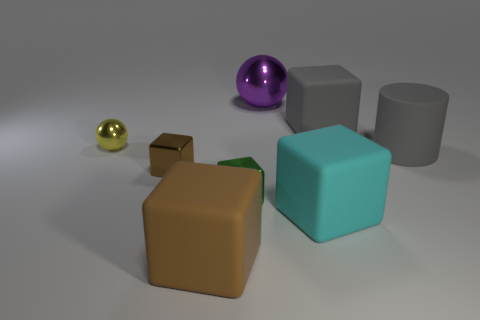There is a rubber cube on the left side of the purple metallic ball; is it the same size as the sphere to the right of the large brown rubber thing?
Offer a very short reply. Yes. There is a brown object in front of the brown metal block; how big is it?
Give a very brief answer. Large. Are there any big shiny things of the same color as the large cylinder?
Your answer should be compact. No. Are there any large gray matte cubes on the left side of the big block behind the cyan matte object?
Your answer should be compact. No. Is the size of the brown metal thing the same as the gray matte thing that is behind the yellow metal thing?
Give a very brief answer. No. Are there any tiny brown metal objects in front of the brown thing that is to the left of the large matte cube that is in front of the big cyan matte object?
Offer a very short reply. No. What is the material of the gray object behind the small yellow metallic ball?
Your answer should be compact. Rubber. Is the brown rubber thing the same size as the yellow ball?
Make the answer very short. No. What color is the big object that is both in front of the large purple shiny thing and on the left side of the cyan object?
Offer a very short reply. Brown. What shape is the tiny yellow thing that is made of the same material as the tiny brown thing?
Make the answer very short. Sphere. 